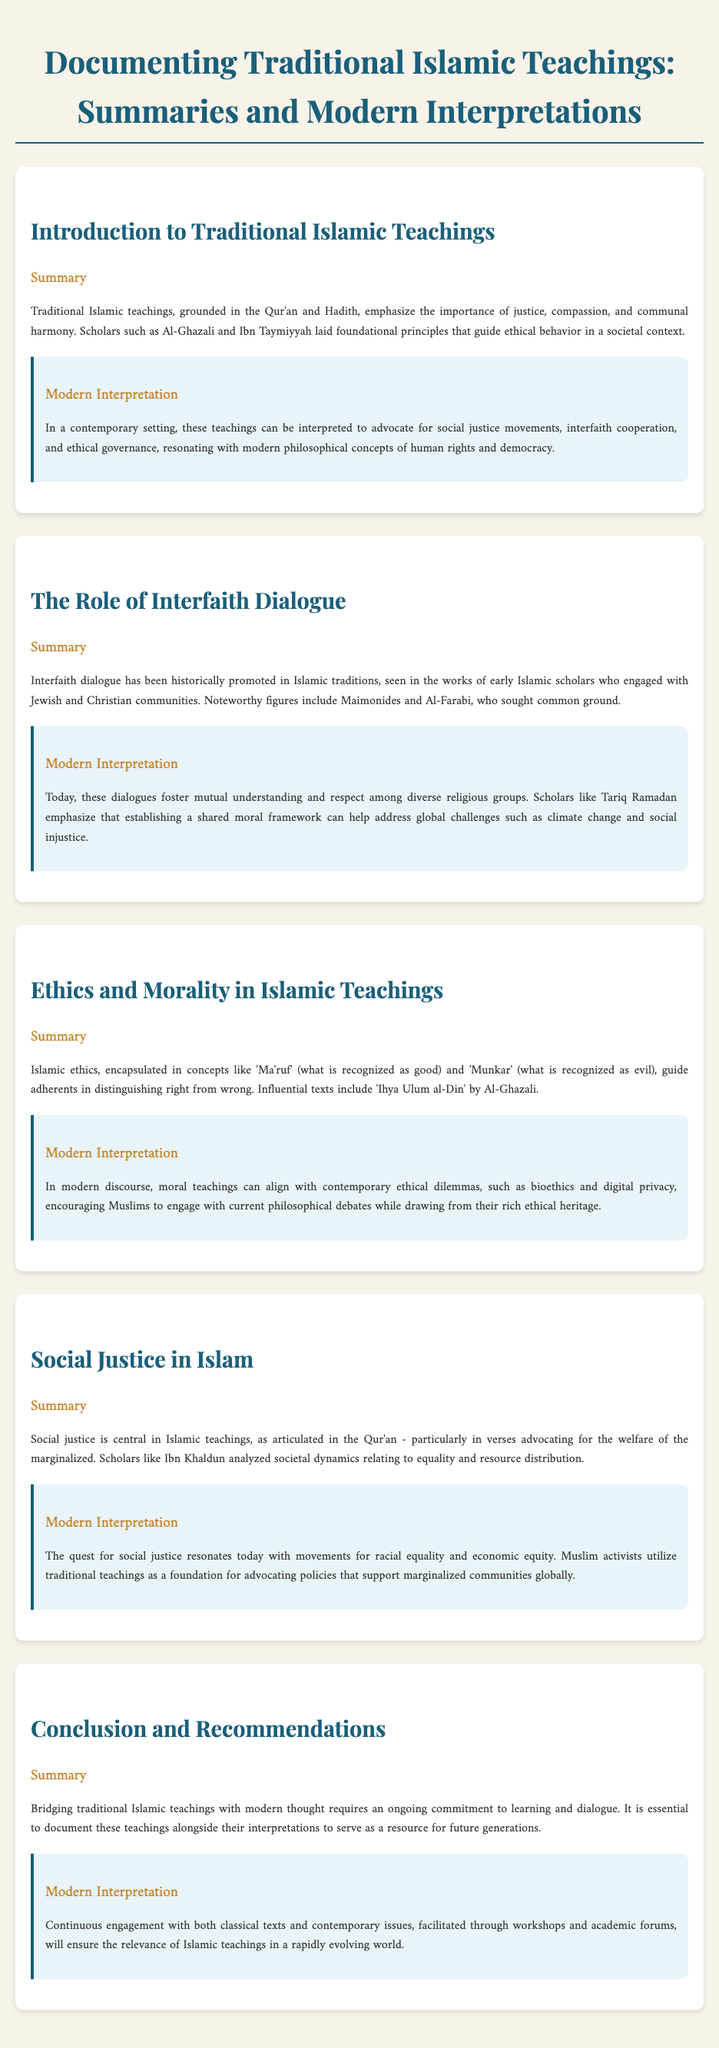What is the main theme of traditional Islamic teachings? The main theme emphasized is justice, compassion, and communal harmony as grounded in the Qur'an and Hadith.
Answer: justice, compassion, and communal harmony Who are two influential scholars mentioned in relation to traditional Islamic teachings? The document cites Al-Ghazali and Ibn Taymiyyah as foundational scholars in Islamic ethics.
Answer: Al-Ghazali and Ibn Taymiyyah What is the historical significance of interfaith dialogue in Islam? It historically promotes engagement with Jewish and Christian communities, as seen in the works of scholars like Maimonides and Al-Farabi.
Answer: engagement with Jewish and Christian communities What modern issue do scholars like Tariq Ramadan associate with interfaith dialogue? Scholars emphasize that a shared moral framework can help address global challenges such as climate change and social injustice.
Answer: climate change and social injustice What concept in Islamic ethics helps distinguish right from wrong? The terms 'Ma'ruf' (what is recognized as good) and 'Munkar' (what is recognized as evil) are central to Islamic ethical teachings.
Answer: Ma'ruf and Munkar Which principle is central to social justice in Islamic teachings? The Qur'an advocates for the welfare of the marginalized, which is fundamental to Islamic views on social justice.
Answer: welfare of the marginalized What method is suggested for bridging traditional Islamic teachings with modern thought? Documenting teachings alongside their interpretations is recommended for future generations.
Answer: documenting teachings alongside interpretations What role do workshops and academic forums play according to the document? Continuous engagement through workshops and forums ensures the relevance of Islamic teachings in a rapidly changing world.
Answer: relevance in a rapidly changing world 